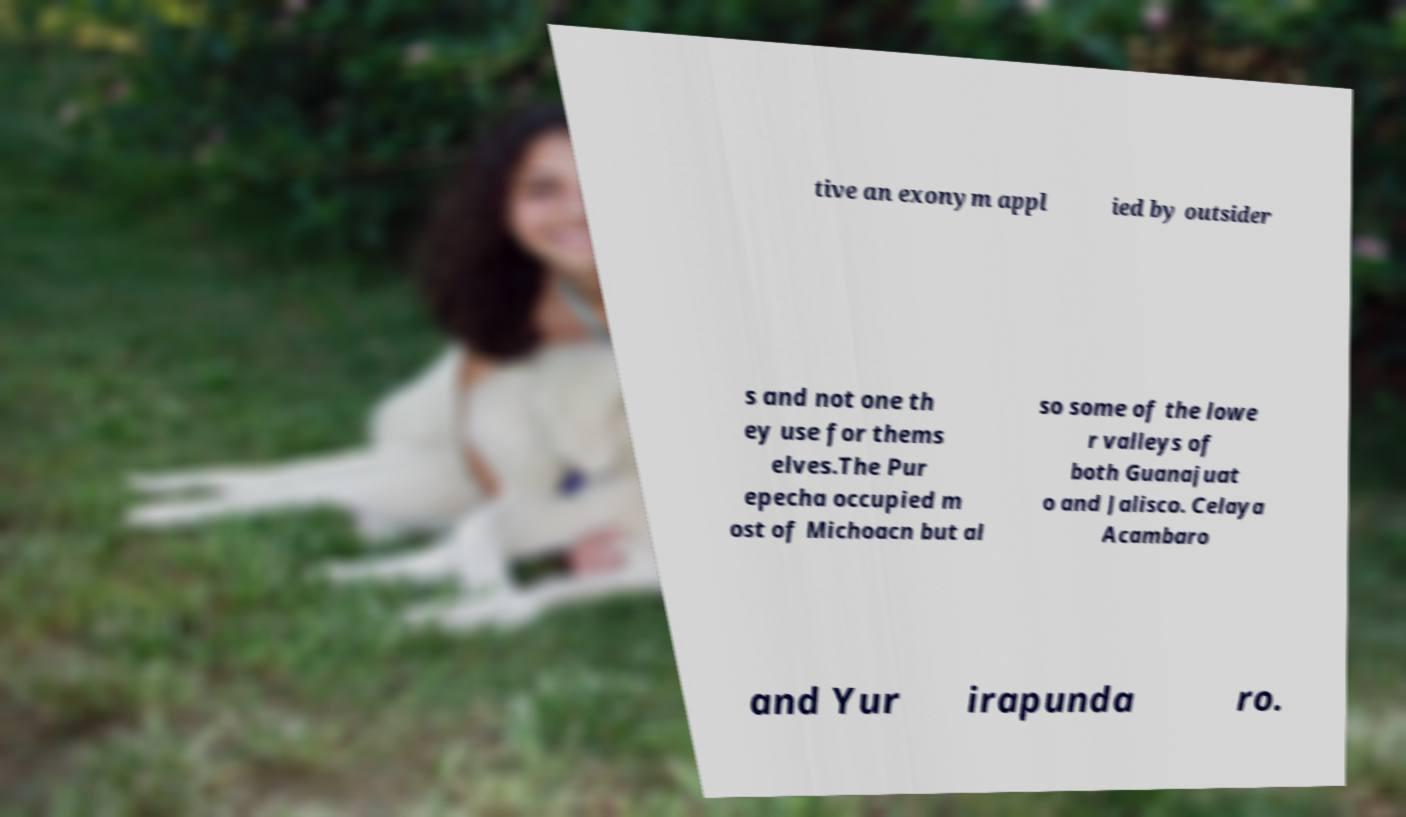Can you read and provide the text displayed in the image?This photo seems to have some interesting text. Can you extract and type it out for me? tive an exonym appl ied by outsider s and not one th ey use for thems elves.The Pur epecha occupied m ost of Michoacn but al so some of the lowe r valleys of both Guanajuat o and Jalisco. Celaya Acambaro and Yur irapunda ro. 